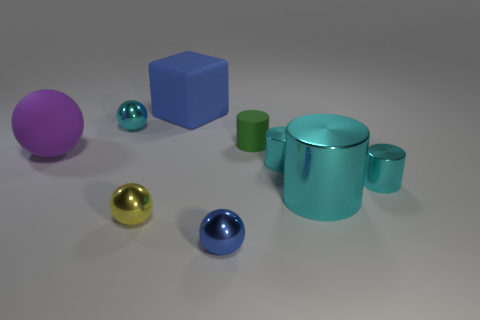Subtract all tiny green matte cylinders. How many cylinders are left? 3 Subtract all gray cubes. How many cyan cylinders are left? 3 Subtract all green cylinders. How many cylinders are left? 3 Subtract 2 balls. How many balls are left? 2 Subtract all cubes. How many objects are left? 8 Subtract all green cubes. Subtract all green balls. How many cubes are left? 1 Add 8 blue shiny objects. How many blue shiny objects are left? 9 Add 7 big things. How many big things exist? 10 Subtract 1 yellow balls. How many objects are left? 8 Subtract all big cubes. Subtract all big purple matte things. How many objects are left? 7 